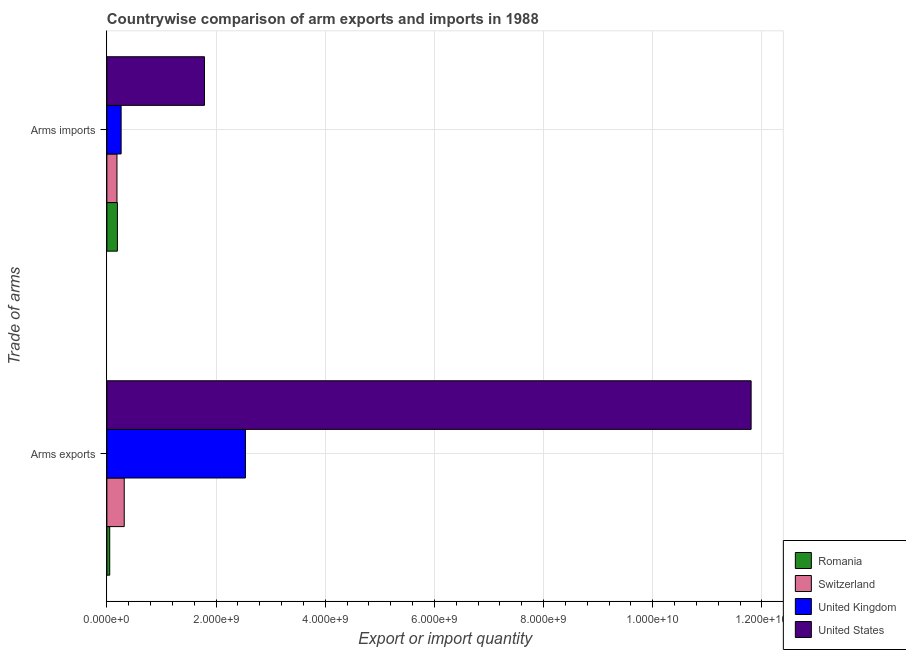How many different coloured bars are there?
Give a very brief answer. 4. Are the number of bars per tick equal to the number of legend labels?
Ensure brevity in your answer.  Yes. Are the number of bars on each tick of the Y-axis equal?
Offer a terse response. Yes. How many bars are there on the 1st tick from the bottom?
Provide a succinct answer. 4. What is the label of the 2nd group of bars from the top?
Provide a short and direct response. Arms exports. What is the arms exports in United Kingdom?
Keep it short and to the point. 2.54e+09. Across all countries, what is the maximum arms imports?
Give a very brief answer. 1.79e+09. Across all countries, what is the minimum arms imports?
Keep it short and to the point. 1.85e+08. In which country was the arms imports maximum?
Ensure brevity in your answer.  United States. In which country was the arms imports minimum?
Provide a short and direct response. Switzerland. What is the total arms imports in the graph?
Offer a very short reply. 2.43e+09. What is the difference between the arms exports in Switzerland and that in United Kingdom?
Give a very brief answer. -2.22e+09. What is the difference between the arms imports in United Kingdom and the arms exports in Romania?
Offer a terse response. 2.09e+08. What is the average arms exports per country?
Your answer should be compact. 3.68e+09. What is the difference between the arms imports and arms exports in Romania?
Your response must be concise. 1.41e+08. What is the ratio of the arms imports in United Kingdom to that in United States?
Provide a short and direct response. 0.15. What does the 1st bar from the top in Arms exports represents?
Give a very brief answer. United States. What is the difference between two consecutive major ticks on the X-axis?
Offer a terse response. 2.00e+09. Are the values on the major ticks of X-axis written in scientific E-notation?
Keep it short and to the point. Yes. Where does the legend appear in the graph?
Ensure brevity in your answer.  Bottom right. How many legend labels are there?
Your response must be concise. 4. How are the legend labels stacked?
Provide a short and direct response. Vertical. What is the title of the graph?
Your answer should be compact. Countrywise comparison of arm exports and imports in 1988. Does "Singapore" appear as one of the legend labels in the graph?
Provide a succinct answer. No. What is the label or title of the X-axis?
Your answer should be very brief. Export or import quantity. What is the label or title of the Y-axis?
Your answer should be very brief. Trade of arms. What is the Export or import quantity in Romania in Arms exports?
Your answer should be very brief. 5.20e+07. What is the Export or import quantity in Switzerland in Arms exports?
Offer a terse response. 3.18e+08. What is the Export or import quantity of United Kingdom in Arms exports?
Make the answer very short. 2.54e+09. What is the Export or import quantity of United States in Arms exports?
Your answer should be very brief. 1.18e+1. What is the Export or import quantity in Romania in Arms imports?
Give a very brief answer. 1.93e+08. What is the Export or import quantity of Switzerland in Arms imports?
Ensure brevity in your answer.  1.85e+08. What is the Export or import quantity of United Kingdom in Arms imports?
Ensure brevity in your answer.  2.61e+08. What is the Export or import quantity in United States in Arms imports?
Provide a short and direct response. 1.79e+09. Across all Trade of arms, what is the maximum Export or import quantity in Romania?
Your answer should be very brief. 1.93e+08. Across all Trade of arms, what is the maximum Export or import quantity in Switzerland?
Provide a succinct answer. 3.18e+08. Across all Trade of arms, what is the maximum Export or import quantity in United Kingdom?
Ensure brevity in your answer.  2.54e+09. Across all Trade of arms, what is the maximum Export or import quantity of United States?
Keep it short and to the point. 1.18e+1. Across all Trade of arms, what is the minimum Export or import quantity in Romania?
Provide a short and direct response. 5.20e+07. Across all Trade of arms, what is the minimum Export or import quantity in Switzerland?
Offer a terse response. 1.85e+08. Across all Trade of arms, what is the minimum Export or import quantity of United Kingdom?
Your answer should be compact. 2.61e+08. Across all Trade of arms, what is the minimum Export or import quantity in United States?
Your response must be concise. 1.79e+09. What is the total Export or import quantity in Romania in the graph?
Offer a terse response. 2.45e+08. What is the total Export or import quantity of Switzerland in the graph?
Your response must be concise. 5.03e+08. What is the total Export or import quantity of United Kingdom in the graph?
Make the answer very short. 2.80e+09. What is the total Export or import quantity in United States in the graph?
Provide a short and direct response. 1.36e+1. What is the difference between the Export or import quantity of Romania in Arms exports and that in Arms imports?
Provide a short and direct response. -1.41e+08. What is the difference between the Export or import quantity of Switzerland in Arms exports and that in Arms imports?
Give a very brief answer. 1.33e+08. What is the difference between the Export or import quantity in United Kingdom in Arms exports and that in Arms imports?
Offer a terse response. 2.28e+09. What is the difference between the Export or import quantity of United States in Arms exports and that in Arms imports?
Make the answer very short. 1.00e+1. What is the difference between the Export or import quantity in Romania in Arms exports and the Export or import quantity in Switzerland in Arms imports?
Provide a succinct answer. -1.33e+08. What is the difference between the Export or import quantity of Romania in Arms exports and the Export or import quantity of United Kingdom in Arms imports?
Give a very brief answer. -2.09e+08. What is the difference between the Export or import quantity in Romania in Arms exports and the Export or import quantity in United States in Arms imports?
Your answer should be compact. -1.74e+09. What is the difference between the Export or import quantity in Switzerland in Arms exports and the Export or import quantity in United Kingdom in Arms imports?
Give a very brief answer. 5.70e+07. What is the difference between the Export or import quantity of Switzerland in Arms exports and the Export or import quantity of United States in Arms imports?
Ensure brevity in your answer.  -1.47e+09. What is the difference between the Export or import quantity of United Kingdom in Arms exports and the Export or import quantity of United States in Arms imports?
Your answer should be compact. 7.50e+08. What is the average Export or import quantity of Romania per Trade of arms?
Your answer should be compact. 1.22e+08. What is the average Export or import quantity of Switzerland per Trade of arms?
Offer a very short reply. 2.52e+08. What is the average Export or import quantity in United Kingdom per Trade of arms?
Keep it short and to the point. 1.40e+09. What is the average Export or import quantity in United States per Trade of arms?
Provide a succinct answer. 6.79e+09. What is the difference between the Export or import quantity in Romania and Export or import quantity in Switzerland in Arms exports?
Provide a short and direct response. -2.66e+08. What is the difference between the Export or import quantity in Romania and Export or import quantity in United Kingdom in Arms exports?
Provide a short and direct response. -2.49e+09. What is the difference between the Export or import quantity in Romania and Export or import quantity in United States in Arms exports?
Make the answer very short. -1.17e+1. What is the difference between the Export or import quantity of Switzerland and Export or import quantity of United Kingdom in Arms exports?
Give a very brief answer. -2.22e+09. What is the difference between the Export or import quantity in Switzerland and Export or import quantity in United States in Arms exports?
Offer a very short reply. -1.15e+1. What is the difference between the Export or import quantity of United Kingdom and Export or import quantity of United States in Arms exports?
Give a very brief answer. -9.26e+09. What is the difference between the Export or import quantity of Romania and Export or import quantity of United Kingdom in Arms imports?
Offer a terse response. -6.80e+07. What is the difference between the Export or import quantity in Romania and Export or import quantity in United States in Arms imports?
Keep it short and to the point. -1.60e+09. What is the difference between the Export or import quantity of Switzerland and Export or import quantity of United Kingdom in Arms imports?
Ensure brevity in your answer.  -7.60e+07. What is the difference between the Export or import quantity of Switzerland and Export or import quantity of United States in Arms imports?
Offer a terse response. -1.60e+09. What is the difference between the Export or import quantity of United Kingdom and Export or import quantity of United States in Arms imports?
Provide a succinct answer. -1.53e+09. What is the ratio of the Export or import quantity of Romania in Arms exports to that in Arms imports?
Make the answer very short. 0.27. What is the ratio of the Export or import quantity of Switzerland in Arms exports to that in Arms imports?
Give a very brief answer. 1.72. What is the ratio of the Export or import quantity of United Kingdom in Arms exports to that in Arms imports?
Make the answer very short. 9.72. What is the ratio of the Export or import quantity of United States in Arms exports to that in Arms imports?
Provide a succinct answer. 6.6. What is the difference between the highest and the second highest Export or import quantity of Romania?
Your answer should be compact. 1.41e+08. What is the difference between the highest and the second highest Export or import quantity of Switzerland?
Offer a terse response. 1.33e+08. What is the difference between the highest and the second highest Export or import quantity in United Kingdom?
Your response must be concise. 2.28e+09. What is the difference between the highest and the second highest Export or import quantity of United States?
Your response must be concise. 1.00e+1. What is the difference between the highest and the lowest Export or import quantity in Romania?
Your response must be concise. 1.41e+08. What is the difference between the highest and the lowest Export or import quantity of Switzerland?
Your answer should be compact. 1.33e+08. What is the difference between the highest and the lowest Export or import quantity of United Kingdom?
Your response must be concise. 2.28e+09. What is the difference between the highest and the lowest Export or import quantity of United States?
Provide a succinct answer. 1.00e+1. 